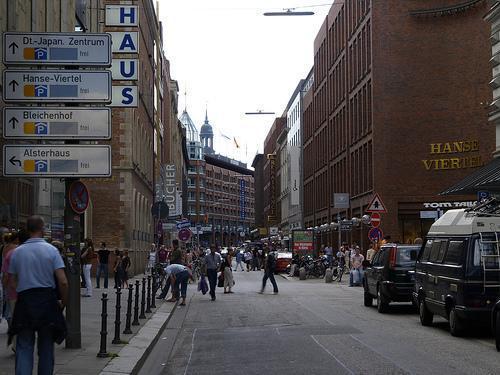How many cars are in the photo?
Give a very brief answer. 3. How many direction signs are on the building?
Give a very brief answer. 4. How many sign boards are there with an arrow pointing left?
Give a very brief answer. 1. 